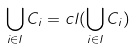<formula> <loc_0><loc_0><loc_500><loc_500>\bigcup _ { i \in I } C _ { i } = c l ( \bigcup _ { i \in I } C _ { i } )</formula> 